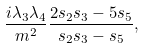<formula> <loc_0><loc_0><loc_500><loc_500>\frac { i \lambda _ { 3 } \lambda _ { 4 } } { m ^ { 2 } } \frac { 2 s _ { 2 } s _ { 3 } - 5 s _ { 5 } } { s _ { 2 } s _ { 3 } - s _ { 5 } } ,</formula> 